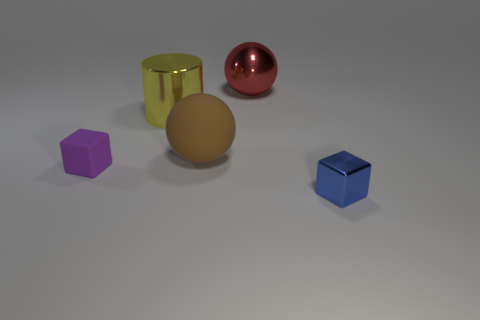What is the color of the other thing that is the same material as the brown object?
Keep it short and to the point. Purple. The big ball behind the ball that is to the left of the sphere that is behind the big matte thing is what color?
Your answer should be compact. Red. Do the purple matte block and the matte thing on the right side of the purple cube have the same size?
Give a very brief answer. No. What number of things are either things that are right of the brown rubber sphere or metal objects on the right side of the red shiny sphere?
Offer a very short reply. 2. The red object that is the same size as the yellow thing is what shape?
Offer a very short reply. Sphere. The big metal object to the left of the large shiny object that is to the right of the large object in front of the yellow thing is what shape?
Provide a succinct answer. Cylinder. Are there an equal number of large yellow objects that are in front of the matte sphere and cyan rubber objects?
Keep it short and to the point. Yes. Is the size of the purple block the same as the brown thing?
Your response must be concise. No. What number of rubber objects are either large red spheres or green spheres?
Your answer should be compact. 0. There is a brown object that is the same size as the red thing; what is its material?
Keep it short and to the point. Rubber. 